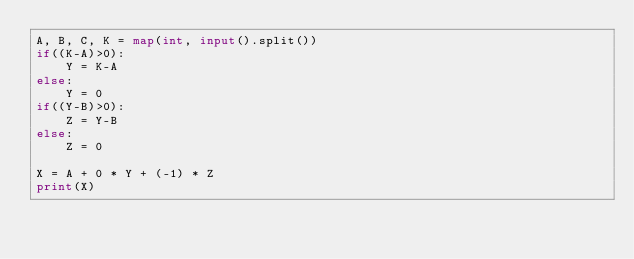<code> <loc_0><loc_0><loc_500><loc_500><_Python_>A, B, C, K = map(int, input().split())
if((K-A)>0):
    Y = K-A
else:
    Y = 0
if((Y-B)>0):
    Z = Y-B
else:
    Z = 0

X = A + 0 * Y + (-1) * Z
print(X)</code> 